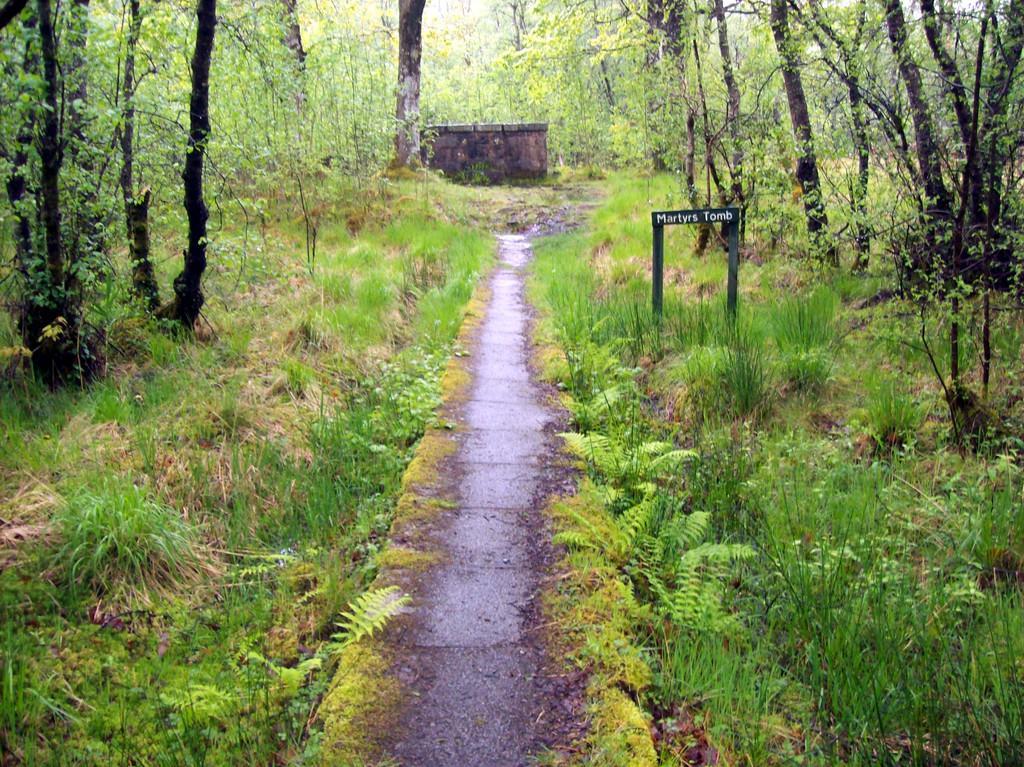Please provide a concise description of this image. In this picture I can see the path in the center and on both the sides, I can see the plants and the trees. On the right side of this picture I can see a board on which there is something is written. 